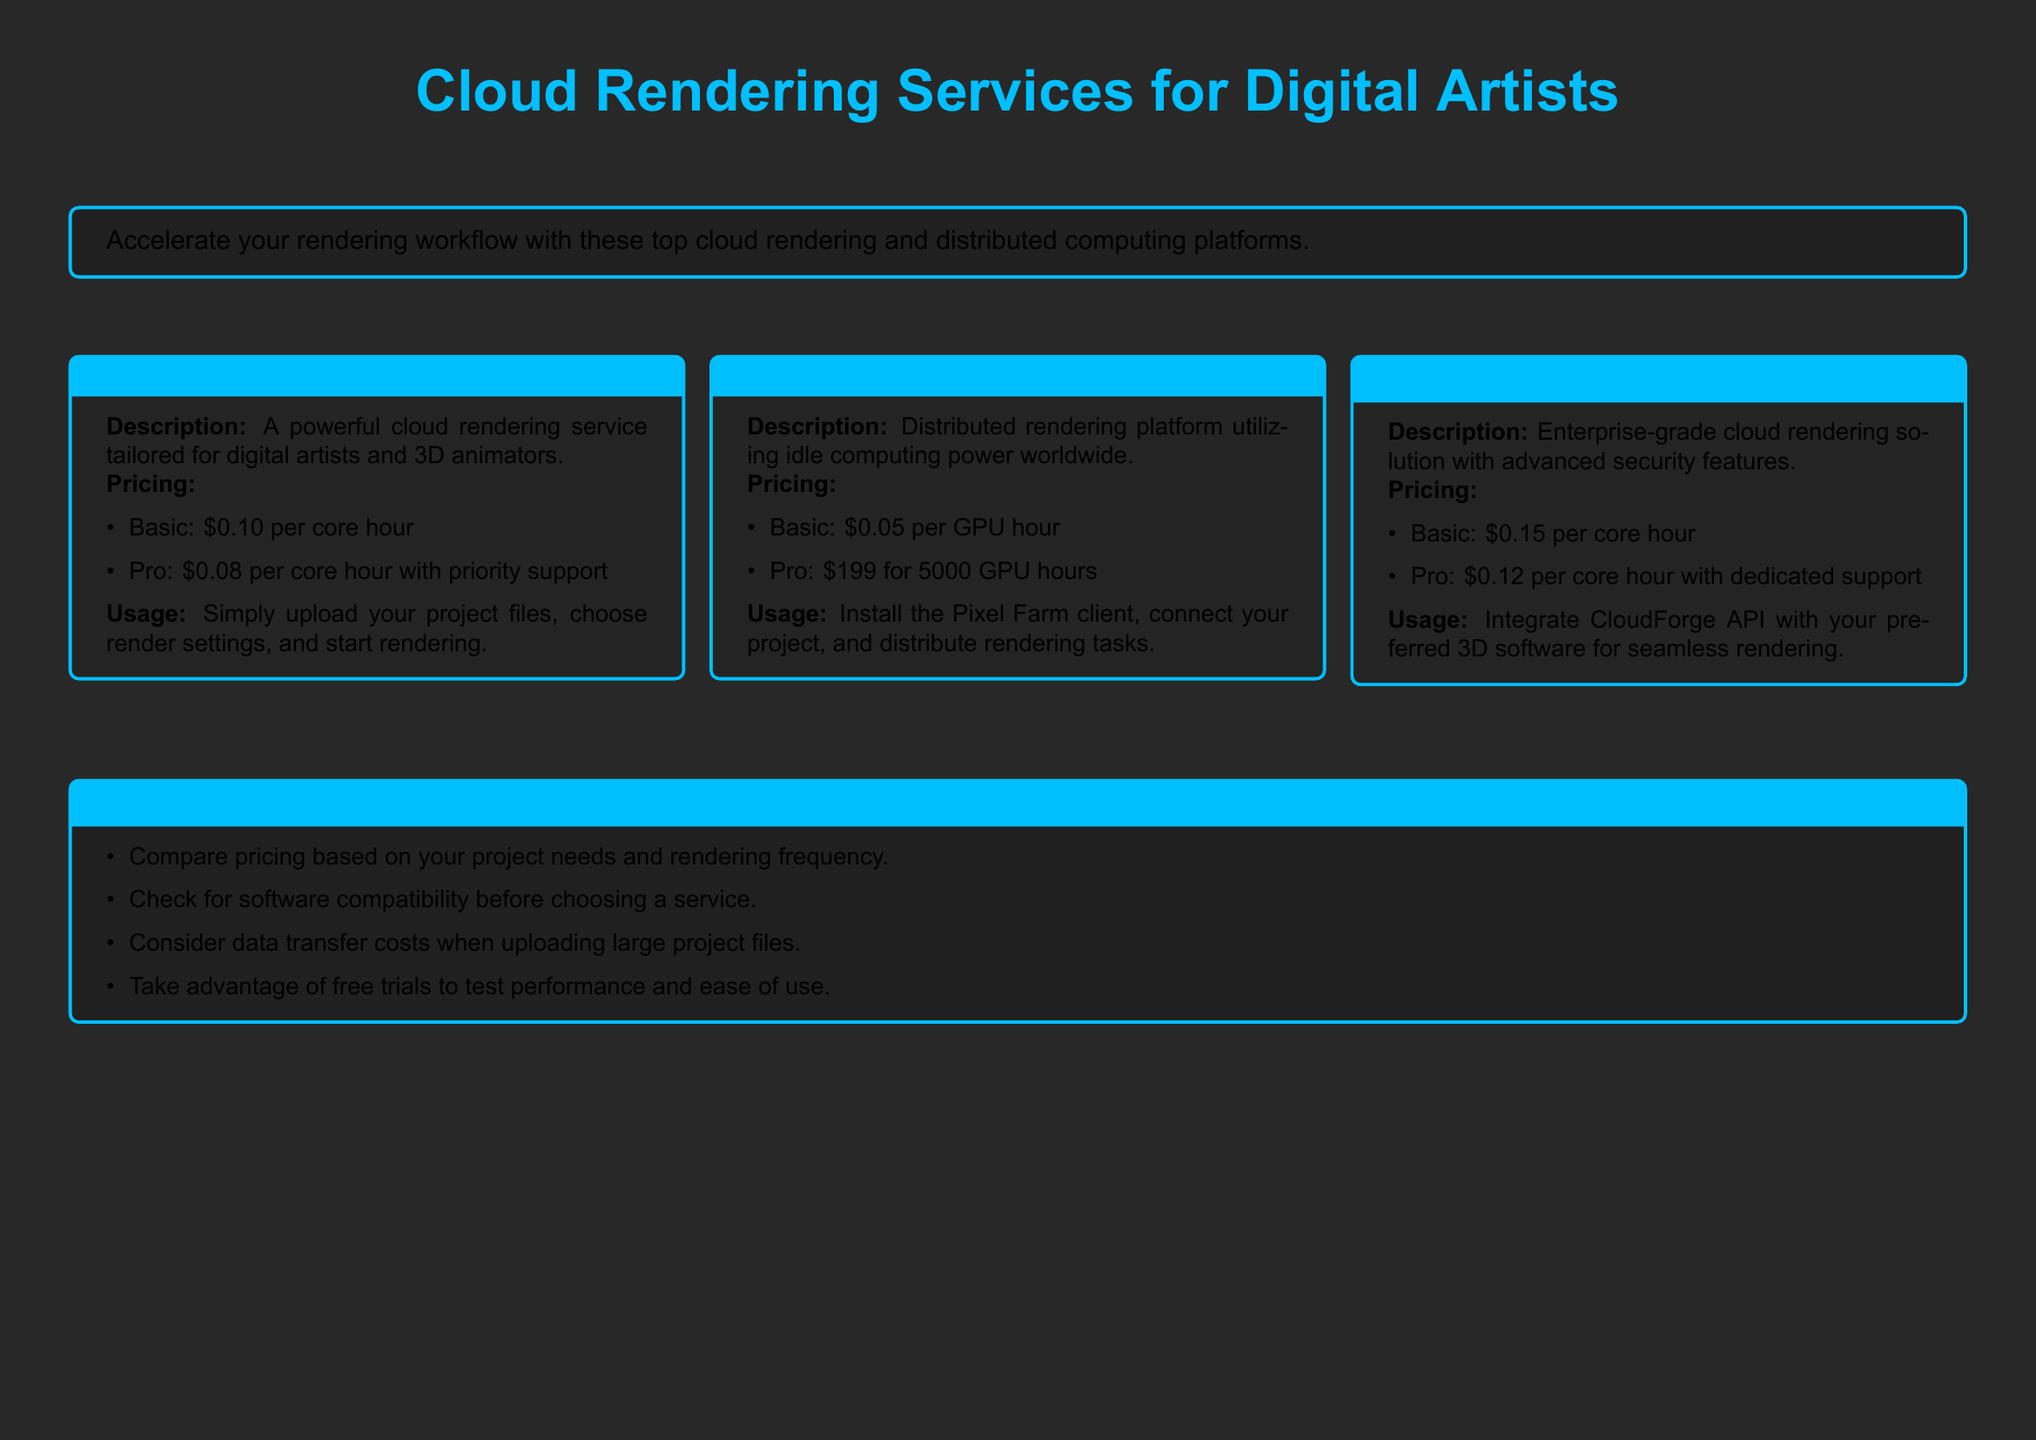what is the name of the first service? The first service listed in the document is Render Pool.
Answer: Render Pool what is the basic pricing for CloudForge? The basic pricing for CloudForge is specified in the pricing section as $0.15 per core hour.
Answer: $0.15 per core hour how much does Pixel Farm charge for 5000 GPU hours? The document provides the pro pricing for Pixel Farm, which is $199 for 5000 GPU hours.
Answer: $199 what is included in priority support for Render Pool? The document mentions that priority support is included in the pro price for Render Pool, which is $0.08 per core hour.
Answer: $0.08 per core hour with priority support what is the main requirement to use CloudForge? The document indicates that integration with CloudForge API is necessary for seamless rendering.
Answer: Integrate CloudForge API what is the recommended action before choosing a cloud service? One of the tips mentioned in the document suggests checking for software compatibility.
Answer: Check for software compatibility what service offers a pricing of $0.05 per GPU hour? Pixel Farm offers a pricing of $0.05 per GPU hour according to the document.
Answer: Pixel Farm what additional benefit do you get with the Pro pricing on Pixel Farm? The document does not specify additional benefits for Pro pricing directly, but mentions the basic and pro pricing options.
Answer: Not specified what can you do to test performance before committing? The document advises to take advantage of free trials to assess performance and usability.
Answer: Take advantage of free trials 